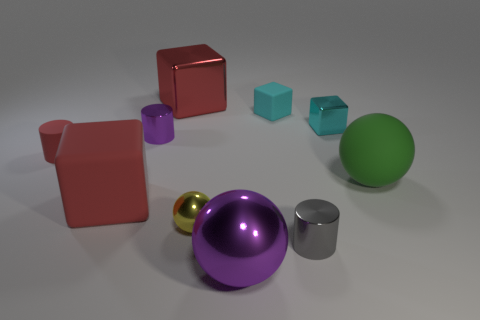Subtract 1 cubes. How many cubes are left? 3 Subtract all blocks. How many objects are left? 6 Add 6 big purple balls. How many big purple balls are left? 7 Add 6 rubber cylinders. How many rubber cylinders exist? 7 Subtract 0 brown blocks. How many objects are left? 10 Subtract all green objects. Subtract all green matte balls. How many objects are left? 8 